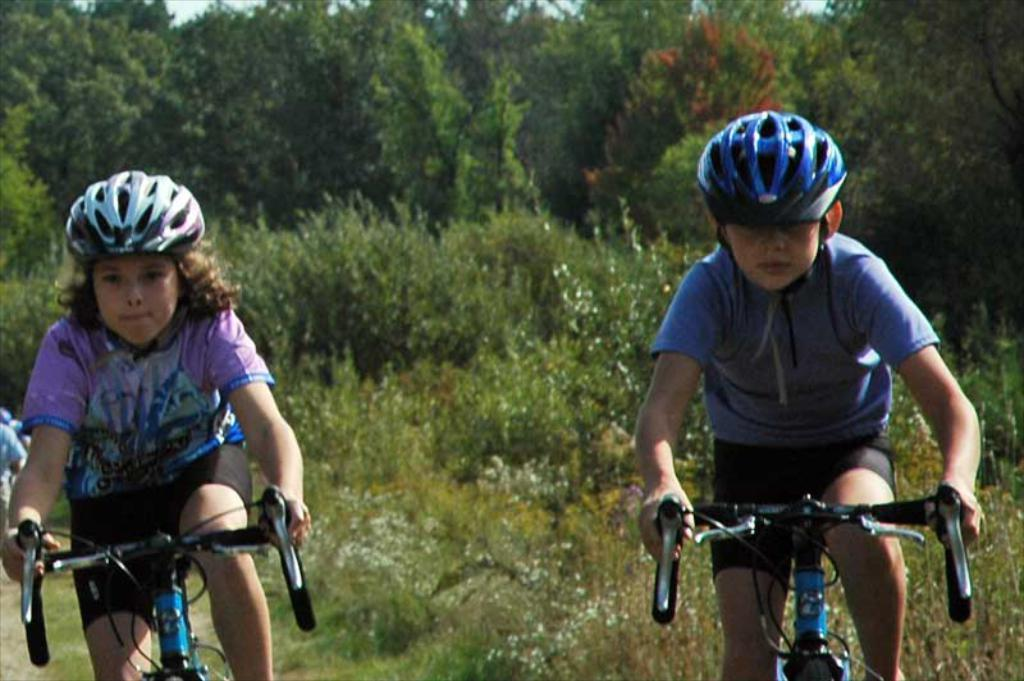How many children are in the image? There are two children in the image. What are the children wearing on their heads? The children are wearing helmets. What activity are the children engaged in? The children are riding a bicycle. What can be seen in the background of the image? There are trees in the background of the image. What type of coat is the sugar wearing in the image? There is no sugar or coat present in the image. Can you describe the ray that is flying over the children in the image? There is no ray present in the image; the children are riding a bicycle with helmets. 